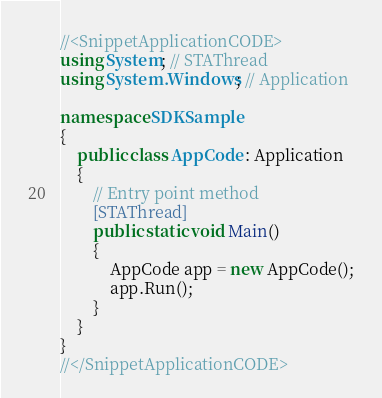<code> <loc_0><loc_0><loc_500><loc_500><_C#_>//<SnippetApplicationCODE>
using System; // STAThread
using System.Windows; // Application

namespace SDKSample
{
    public class AppCode : Application
    {
        // Entry point method
        [STAThread]
        public static void Main()
        {
            AppCode app = new AppCode();
            app.Run();
        }
    }
}
//</SnippetApplicationCODE></code> 